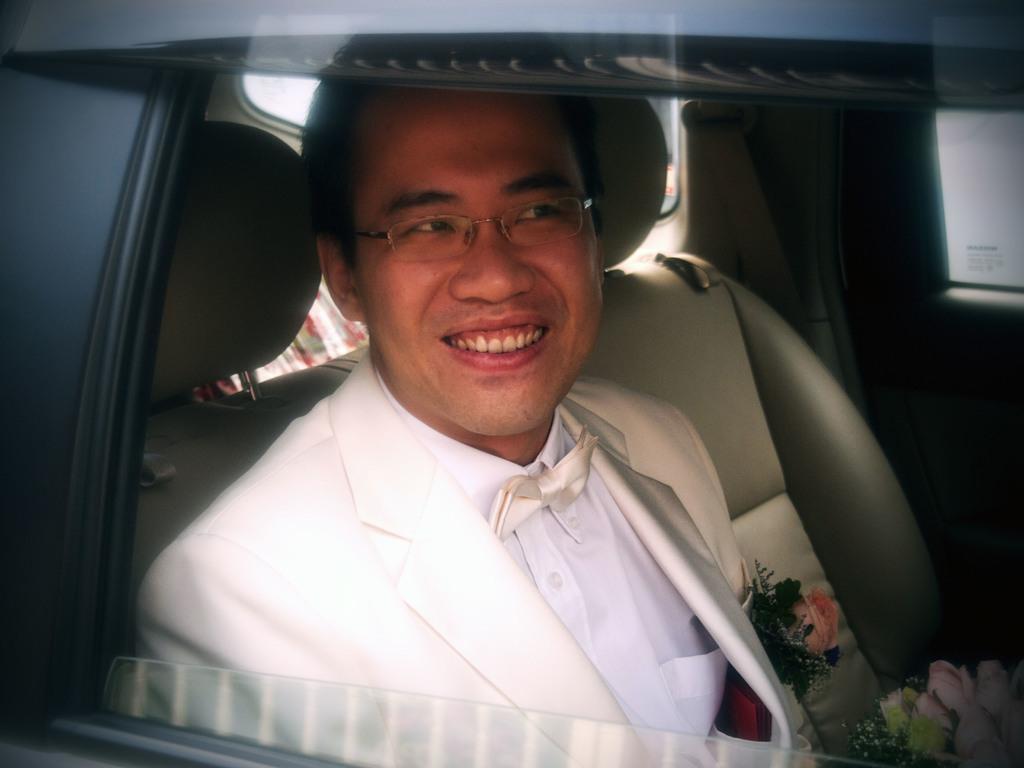Could you give a brief overview of what you see in this image? In this picture I can see a man sitting in a vehicle and I see that he is wearing a suit. I can also see that he is smiling. On the right side of this picture I can see few flowers. 